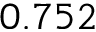<formula> <loc_0><loc_0><loc_500><loc_500>0 . 7 5 2</formula> 